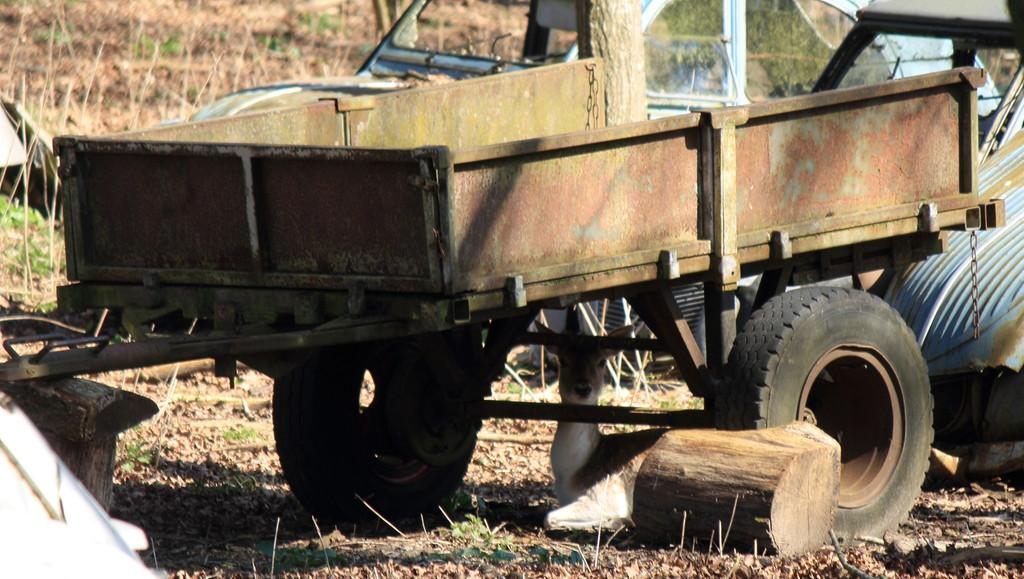What types of objects are on the ground in the image? There are vehicles on the ground in the image. What material can be seen in the image? Wood is visible in the image. What type of living creature is in the image? There is an animal in the image. What type of vegetation is present in the image? There is grass and plants in the image. What time of day might the image have been taken? The image was likely taken during the day, as there is sufficient light to see the details. What type of dinner is being served in the image? There is no dinner present in the image; it features vehicles, wood, an animal, grass, and plants. How does the animal in the image demand attention? The image does not show the animal demanding attention; it simply depicts the animal in its environment. 